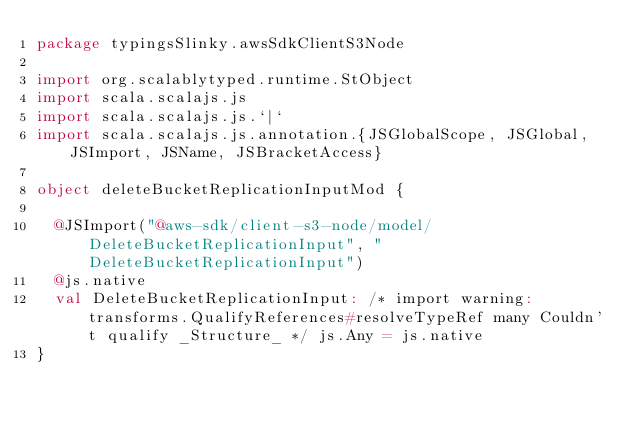Convert code to text. <code><loc_0><loc_0><loc_500><loc_500><_Scala_>package typingsSlinky.awsSdkClientS3Node

import org.scalablytyped.runtime.StObject
import scala.scalajs.js
import scala.scalajs.js.`|`
import scala.scalajs.js.annotation.{JSGlobalScope, JSGlobal, JSImport, JSName, JSBracketAccess}

object deleteBucketReplicationInputMod {
  
  @JSImport("@aws-sdk/client-s3-node/model/DeleteBucketReplicationInput", "DeleteBucketReplicationInput")
  @js.native
  val DeleteBucketReplicationInput: /* import warning: transforms.QualifyReferences#resolveTypeRef many Couldn't qualify _Structure_ */ js.Any = js.native
}
</code> 